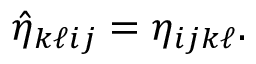Convert formula to latex. <formula><loc_0><loc_0><loc_500><loc_500>\begin{array} { r } { \hat { \eta } _ { k \ell i j } = \eta _ { i j k \ell } . } \end{array}</formula> 